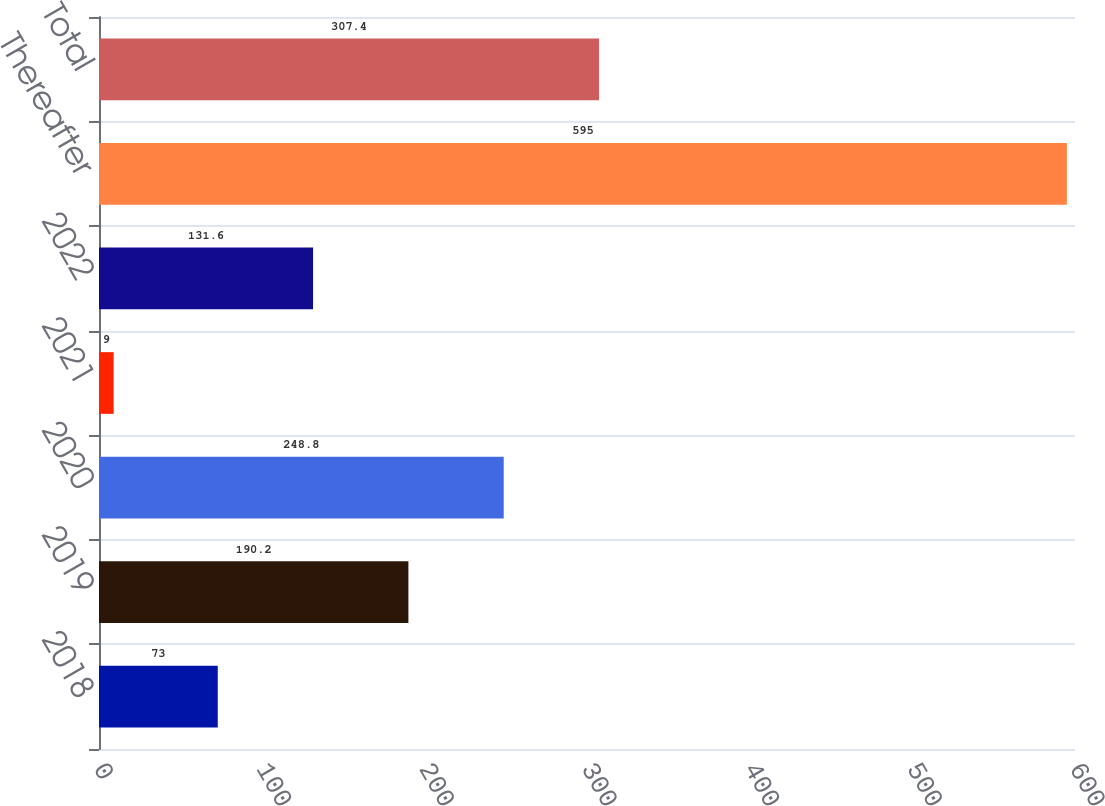Convert chart. <chart><loc_0><loc_0><loc_500><loc_500><bar_chart><fcel>2018<fcel>2019<fcel>2020<fcel>2021<fcel>2022<fcel>Thereafter<fcel>Total<nl><fcel>73<fcel>190.2<fcel>248.8<fcel>9<fcel>131.6<fcel>595<fcel>307.4<nl></chart> 